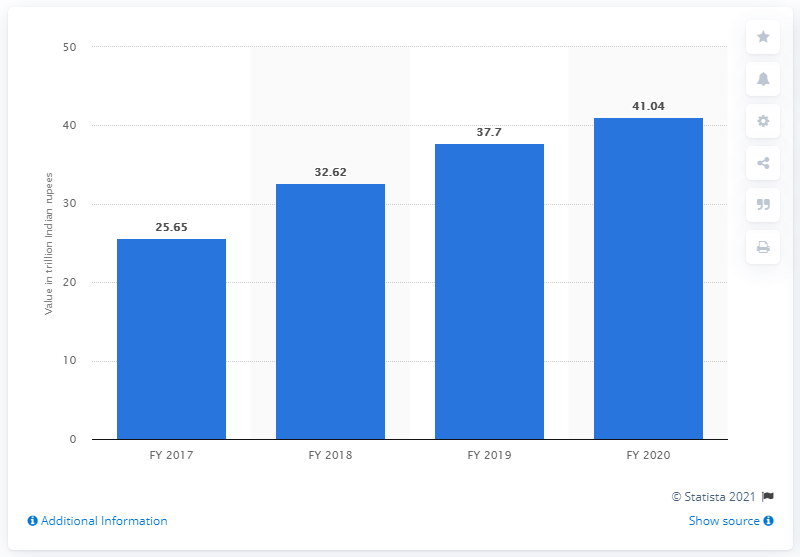Draw attention to some important aspects in this diagram. According to data from fiscal year 2020, private Indian banks received a total of 41.04 rupees in deposits. The total amount of deposits for the previous fiscal year was 41.04... In fiscal year 2020, HDFC Bank deposited 41.04. 